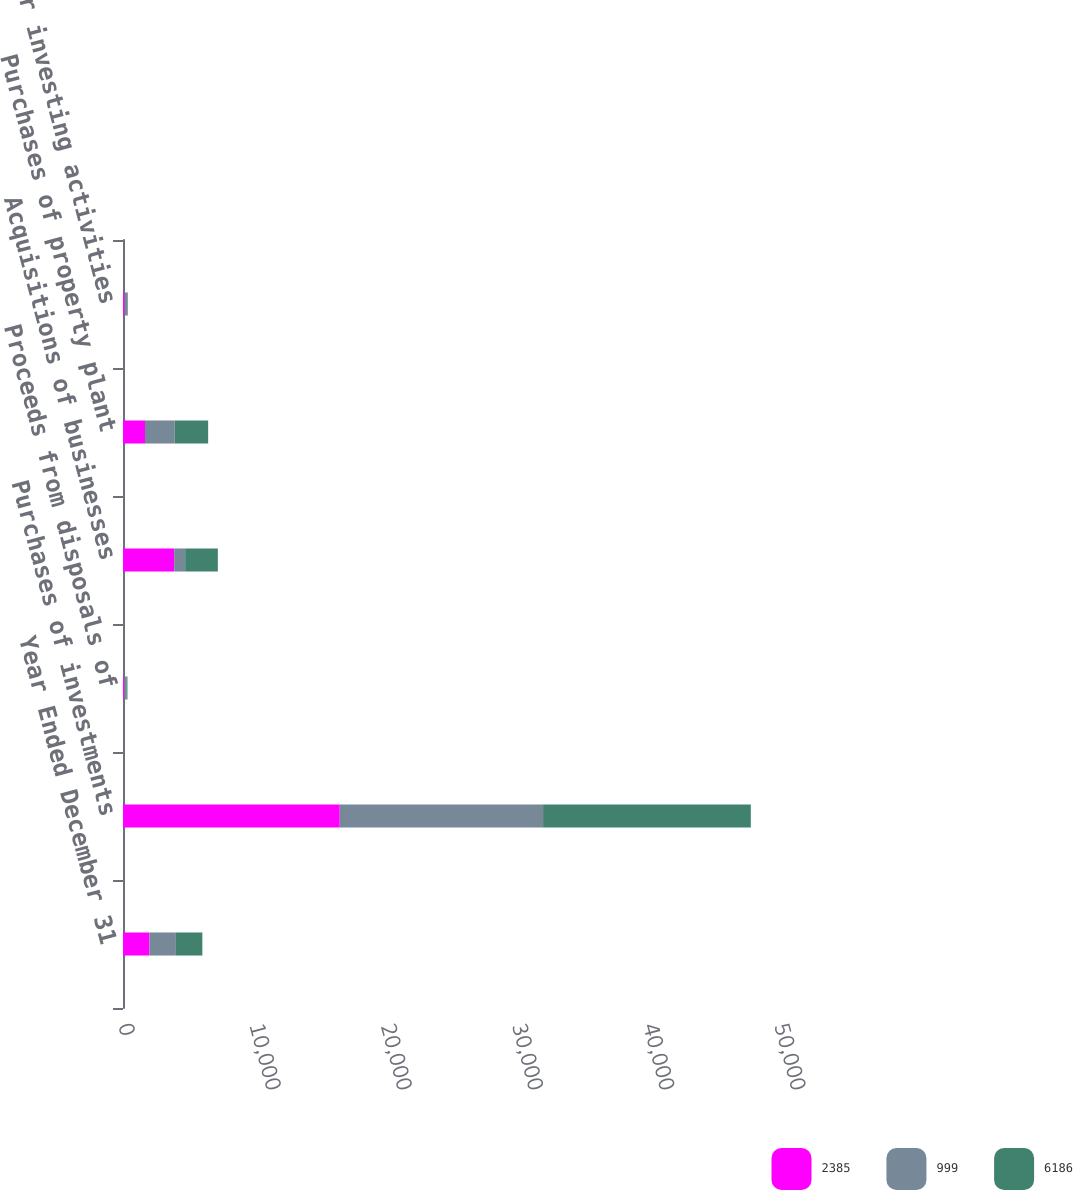Convert chart to OTSL. <chart><loc_0><loc_0><loc_500><loc_500><stacked_bar_chart><ecel><fcel>Year Ended December 31<fcel>Purchases of investments<fcel>Proceeds from disposals of<fcel>Acquisitions of businesses<fcel>Purchases of property plant<fcel>Other investing activities<nl><fcel>2385<fcel>2017<fcel>16520<fcel>104<fcel>3900<fcel>1675<fcel>126<nl><fcel>999<fcel>2016<fcel>15499<fcel>150<fcel>838<fcel>2262<fcel>209<nl><fcel>6186<fcel>2015<fcel>15831<fcel>85<fcel>2491<fcel>2553<fcel>40<nl></chart> 